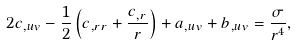<formula> <loc_0><loc_0><loc_500><loc_500>2 c _ { , u v } - \frac { 1 } { 2 } \left ( c _ { , r r } + \frac { c _ { , r } } { r } \right ) + a _ { , u v } + b _ { , u v } = \frac { \sigma } { r ^ { 4 } } ,</formula> 